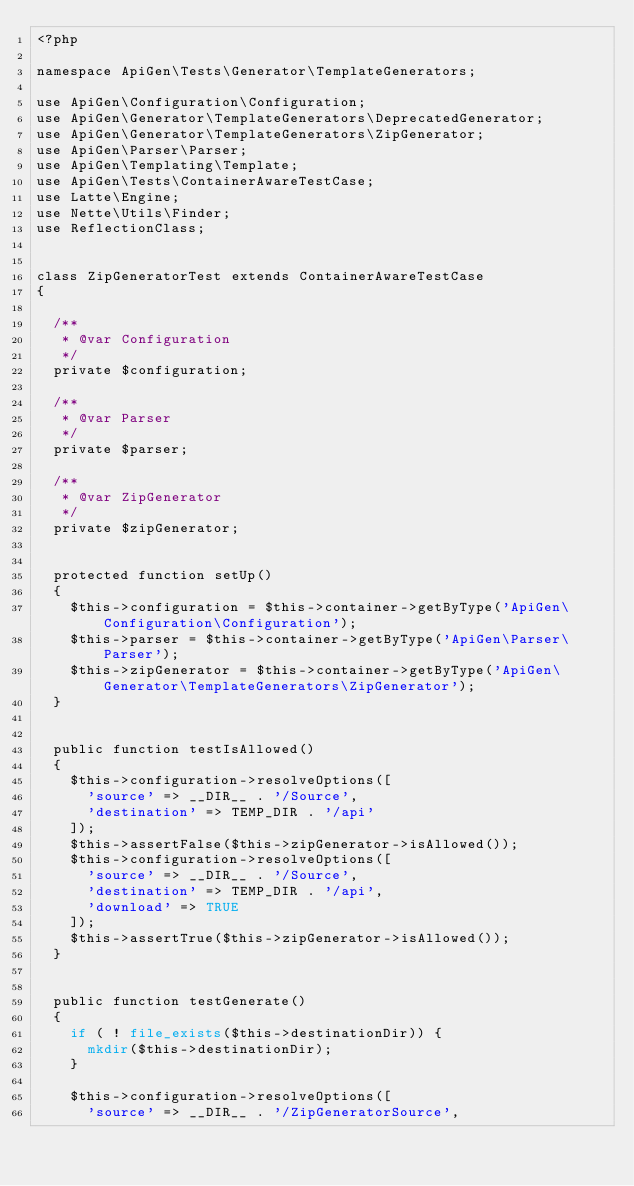<code> <loc_0><loc_0><loc_500><loc_500><_PHP_><?php

namespace ApiGen\Tests\Generator\TemplateGenerators;

use ApiGen\Configuration\Configuration;
use ApiGen\Generator\TemplateGenerators\DeprecatedGenerator;
use ApiGen\Generator\TemplateGenerators\ZipGenerator;
use ApiGen\Parser\Parser;
use ApiGen\Templating\Template;
use ApiGen\Tests\ContainerAwareTestCase;
use Latte\Engine;
use Nette\Utils\Finder;
use ReflectionClass;


class ZipGeneratorTest extends ContainerAwareTestCase
{

	/**
	 * @var Configuration
	 */
	private $configuration;

	/**
	 * @var Parser
	 */
	private $parser;

	/**
	 * @var ZipGenerator
	 */
	private $zipGenerator;


	protected function setUp()
	{
		$this->configuration = $this->container->getByType('ApiGen\Configuration\Configuration');
		$this->parser = $this->container->getByType('ApiGen\Parser\Parser');
		$this->zipGenerator = $this->container->getByType('ApiGen\Generator\TemplateGenerators\ZipGenerator');
	}


	public function testIsAllowed()
	{
		$this->configuration->resolveOptions([
			'source' => __DIR__ . '/Source',
			'destination' => TEMP_DIR . '/api'
		]);
		$this->assertFalse($this->zipGenerator->isAllowed());
		$this->configuration->resolveOptions([
			'source' => __DIR__ . '/Source',
			'destination' => TEMP_DIR . '/api',
			'download' => TRUE
		]);
		$this->assertTrue($this->zipGenerator->isAllowed());
	}


	public function testGenerate()
	{
		if ( ! file_exists($this->destinationDir)) {
			mkdir($this->destinationDir);
		}

		$this->configuration->resolveOptions([
			'source' => __DIR__ . '/ZipGeneratorSource',</code> 